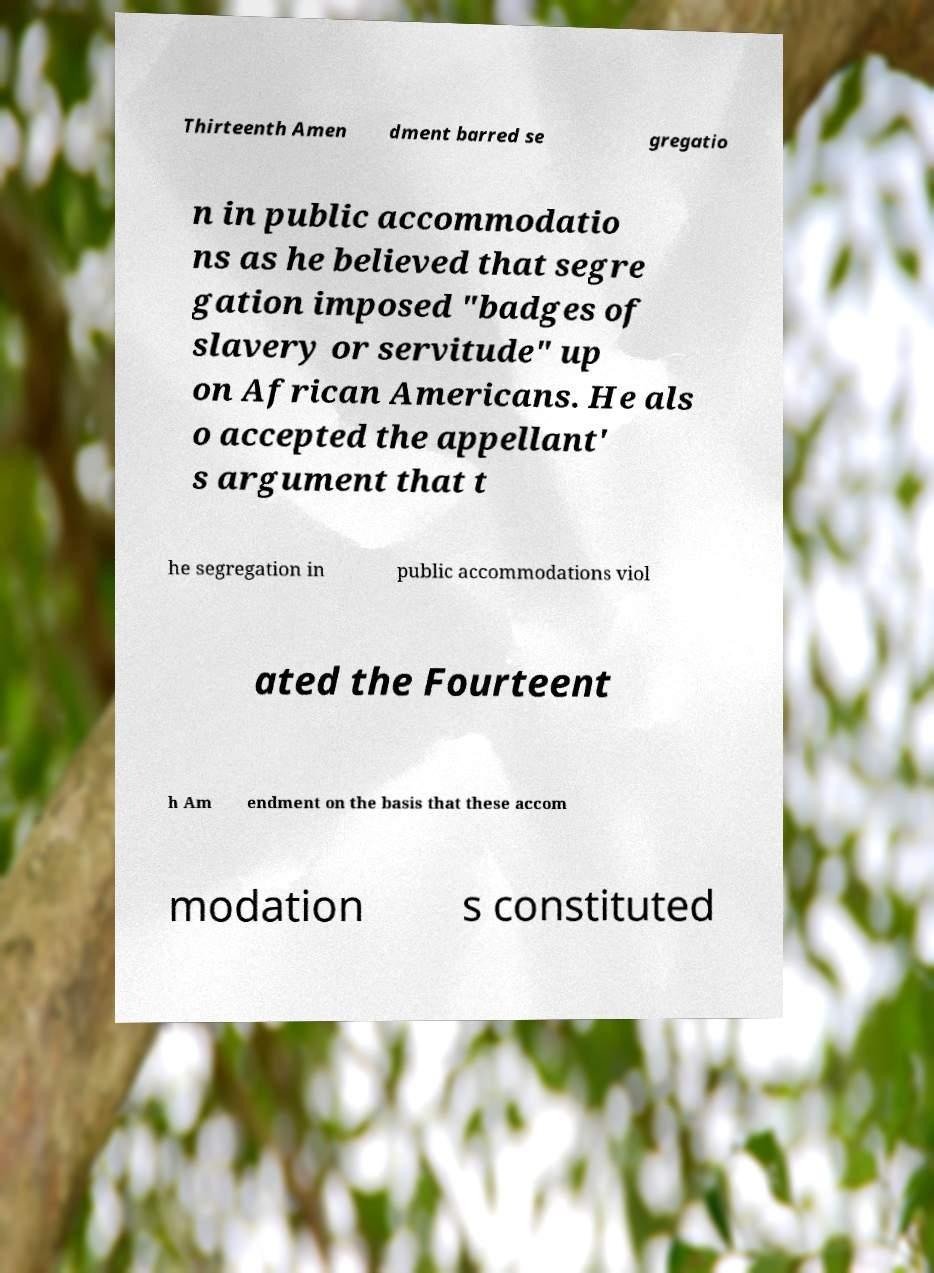Could you assist in decoding the text presented in this image and type it out clearly? Thirteenth Amen dment barred se gregatio n in public accommodatio ns as he believed that segre gation imposed "badges of slavery or servitude" up on African Americans. He als o accepted the appellant' s argument that t he segregation in public accommodations viol ated the Fourteent h Am endment on the basis that these accom modation s constituted 